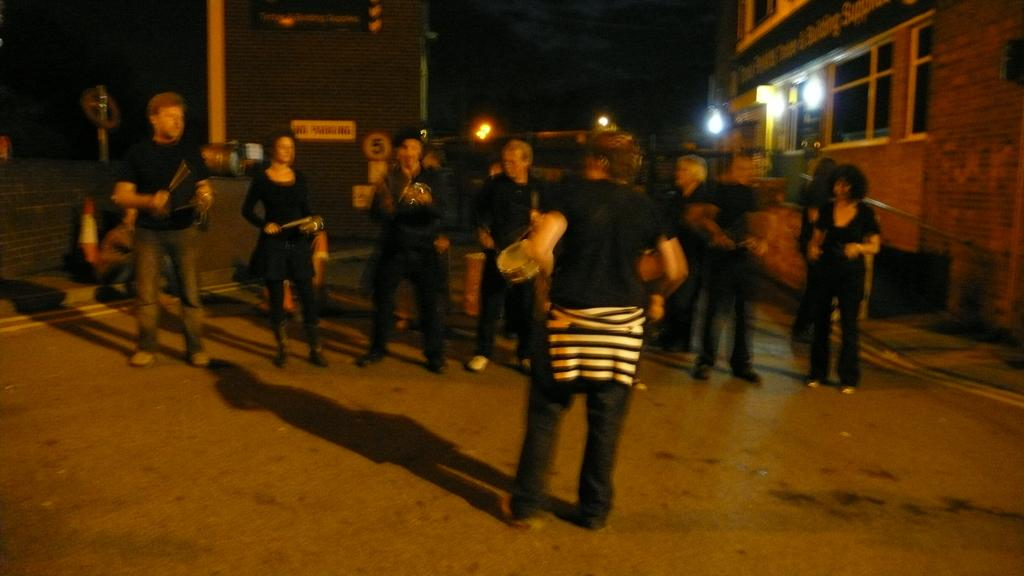Who or what is present in the image? There are people in the image. What are the people doing in the image? The people are holding musical instruments. What can be seen in the distance in the image? There are buildings and lights visible in the background of the image. What type of silk fabric is draped over the buildings in the image? There is no silk fabric present in the image; the buildings are not draped with any fabric. 